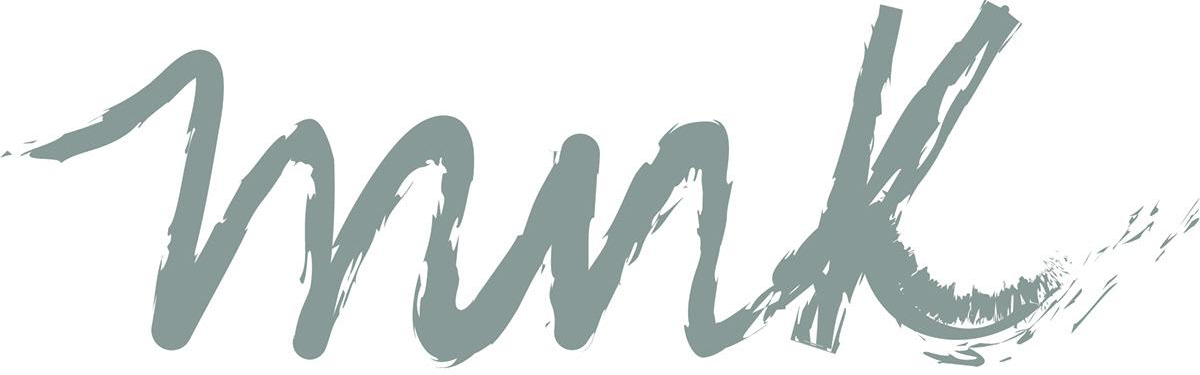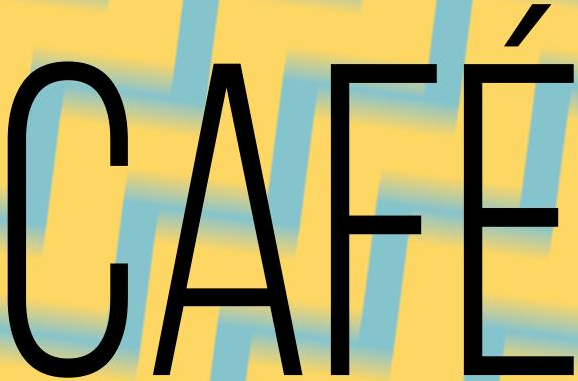What text appears in these images from left to right, separated by a semicolon? mnk; CAFÉ 